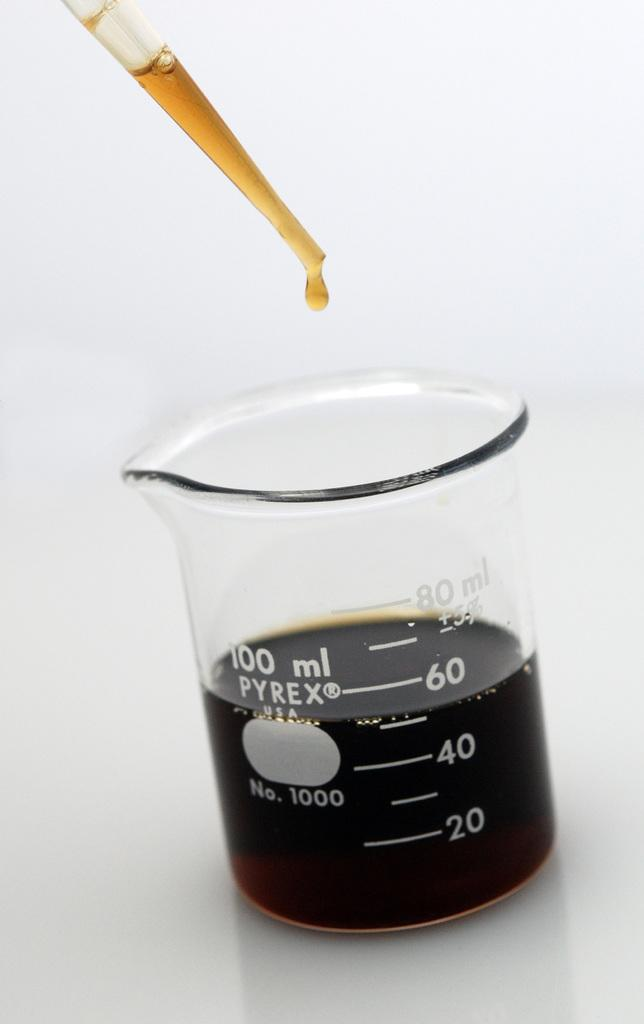<image>
Summarize the visual content of the image. A pyrex measuring cup with a dark brown liquid in it 